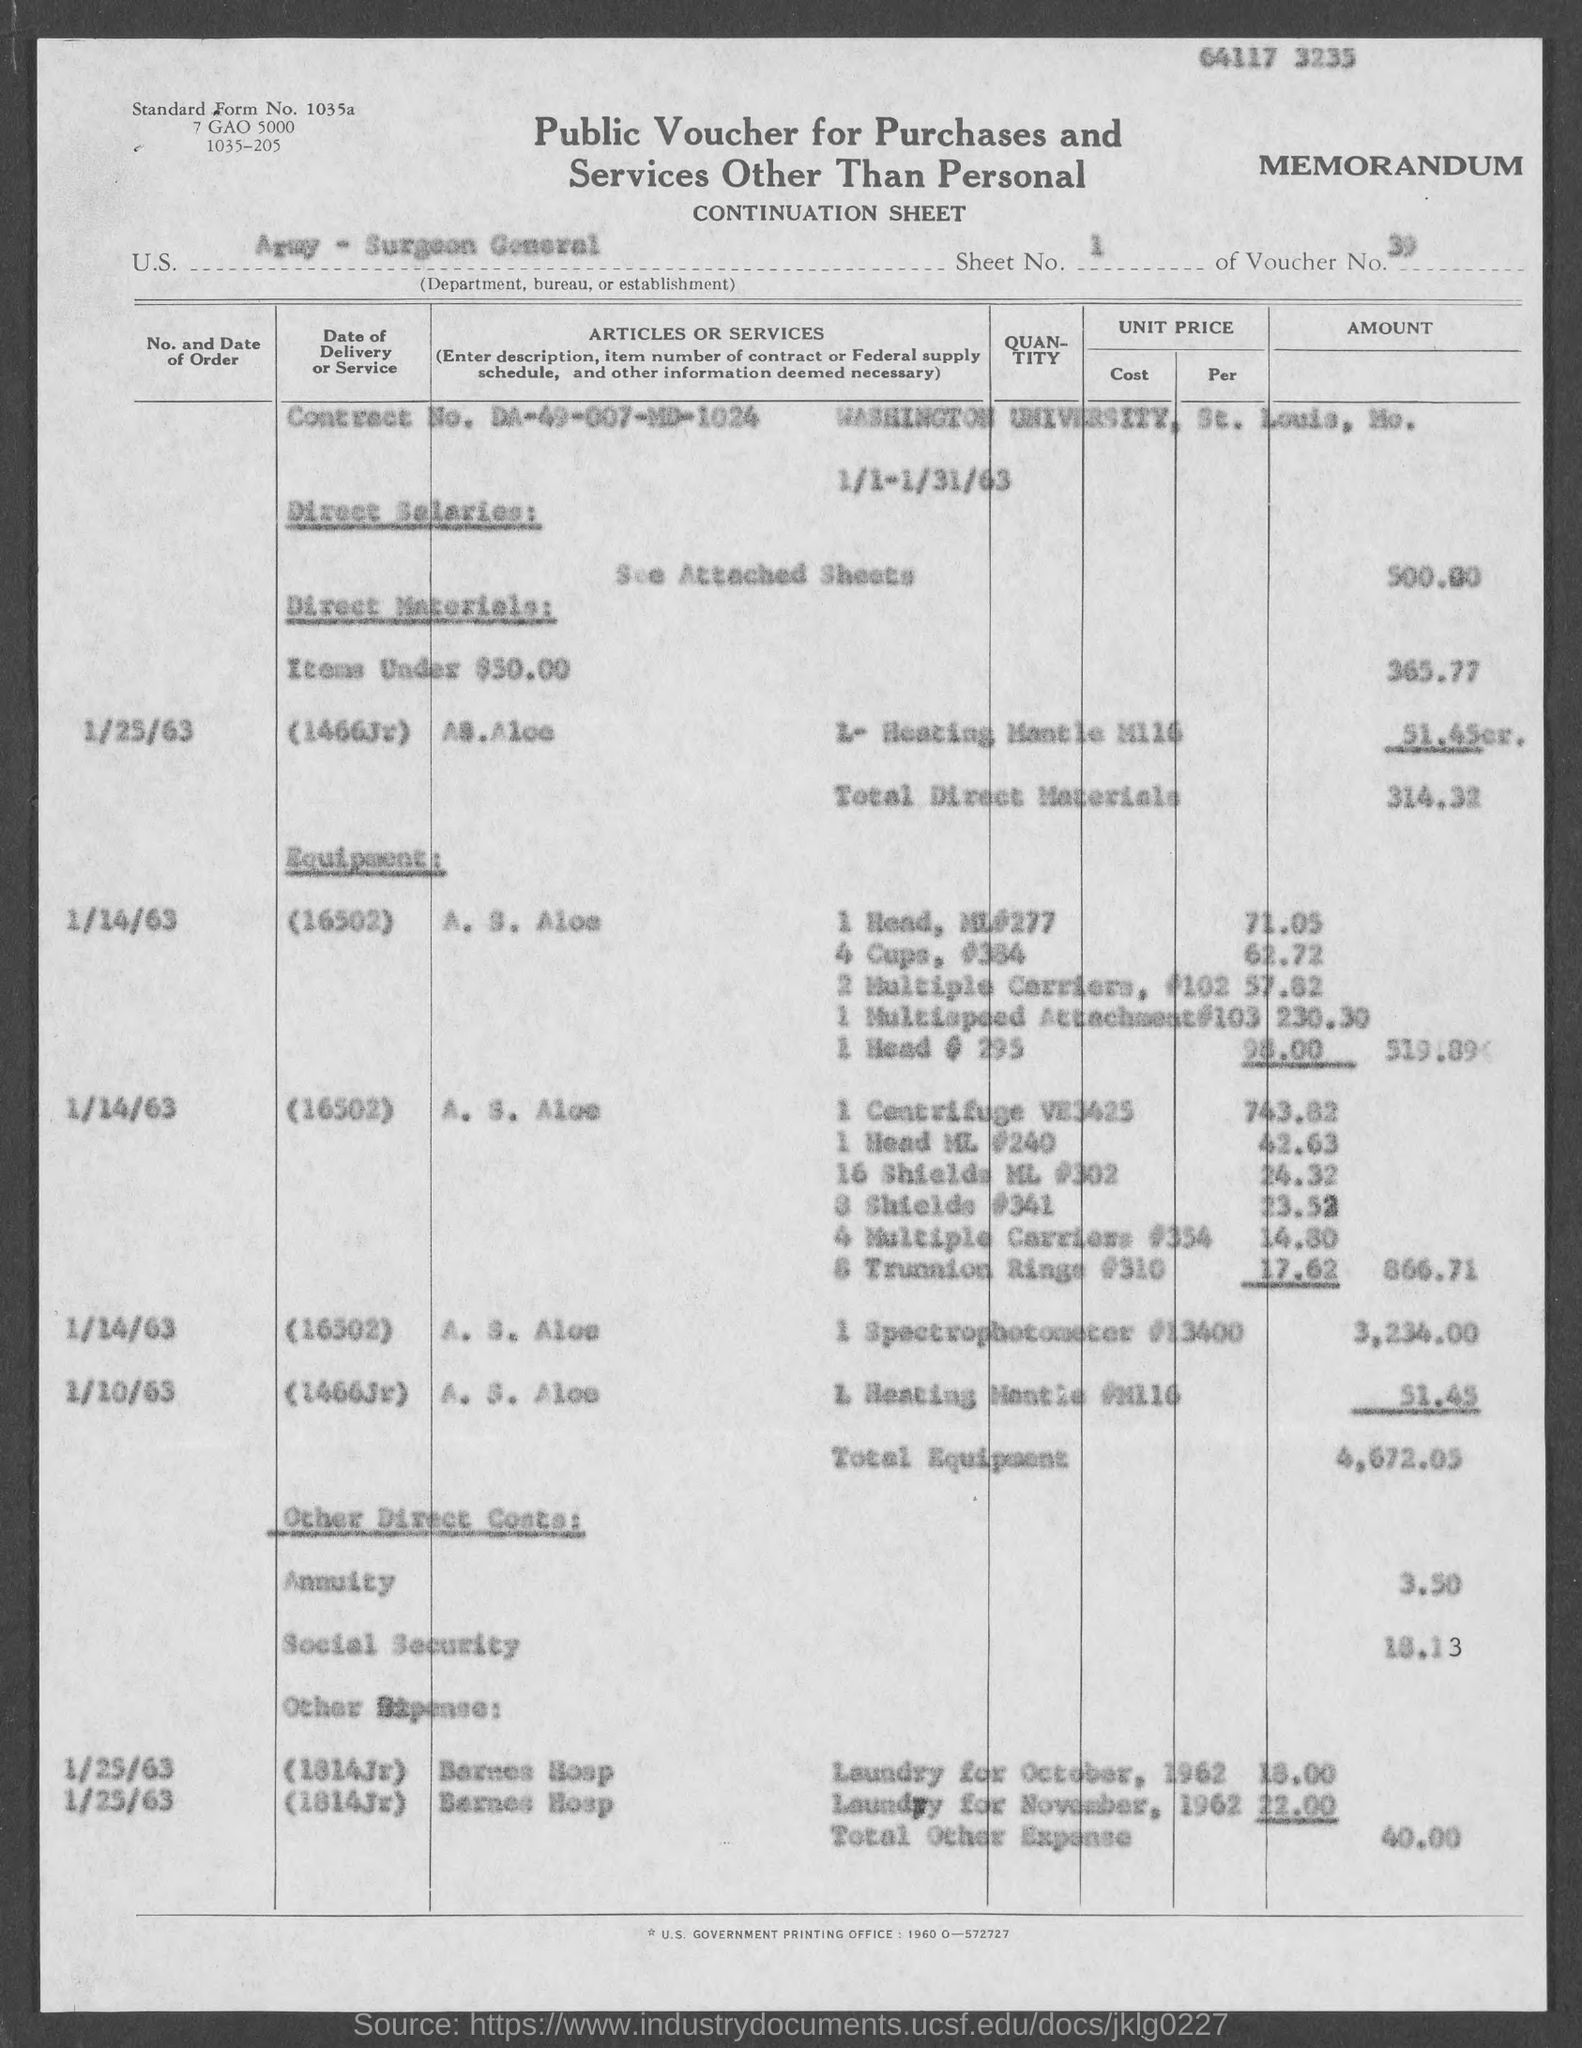What is the sheet no.?
Offer a very short reply. 1. What is the voucher no.?
Make the answer very short. 39. What is the standard form no.?
Your answer should be very brief. 1035a. What is the contract no.?
Your response must be concise. DA-49-007-MD-1024. In which city is washington university at ?
Ensure brevity in your answer.  St. Louis. What is total direct materials ?
Keep it short and to the point. 314.32. What is total equipment ?
Provide a succinct answer. 4672.05. What is total other expense?
Your answer should be very brief. 40.00. 